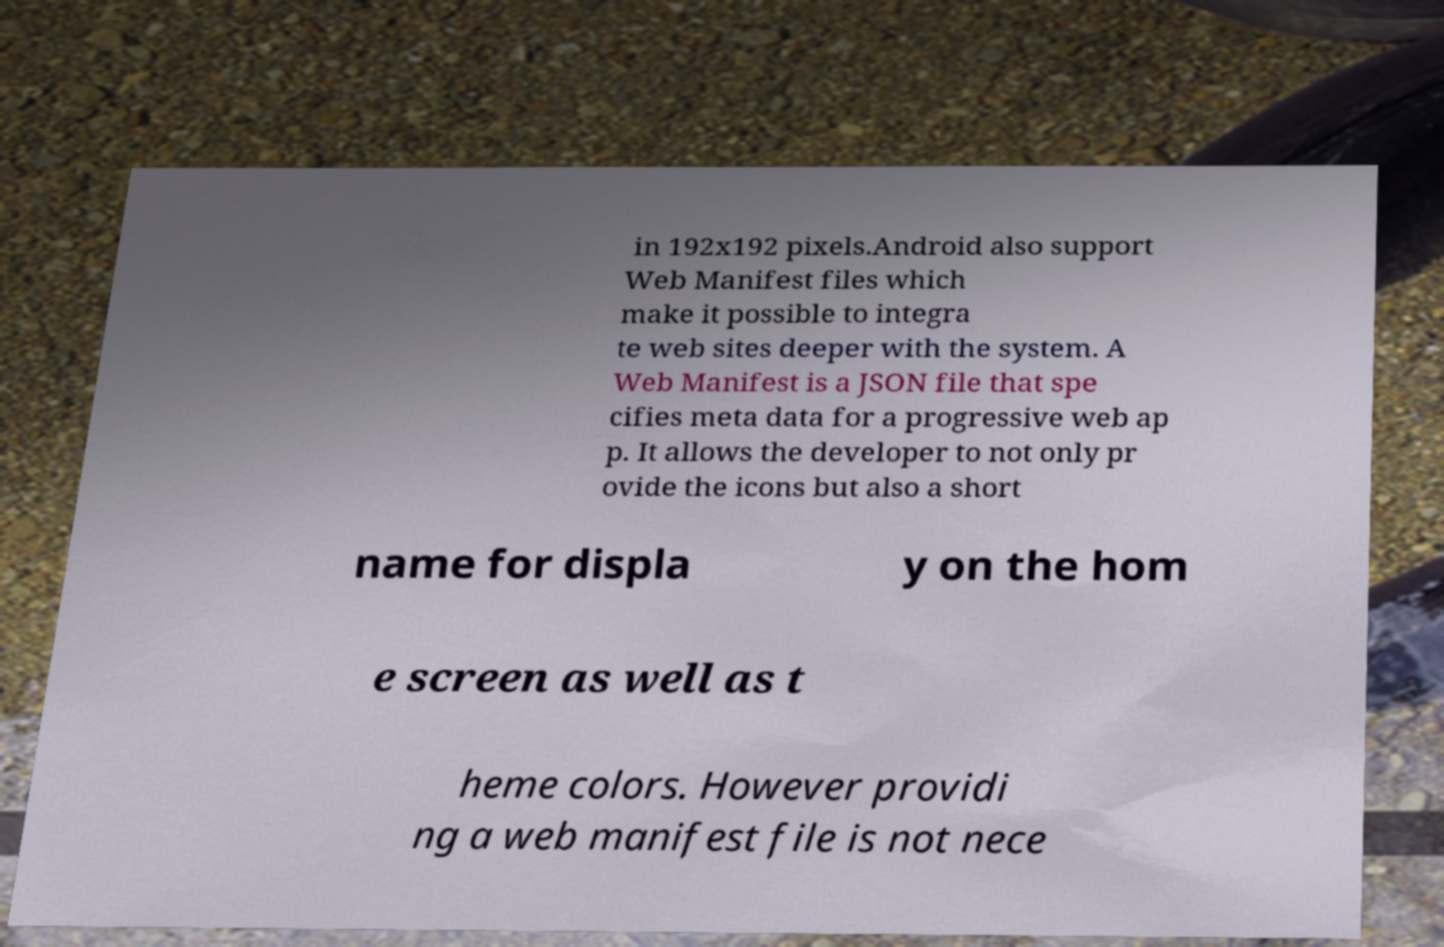Can you read and provide the text displayed in the image?This photo seems to have some interesting text. Can you extract and type it out for me? in 192x192 pixels.Android also support Web Manifest files which make it possible to integra te web sites deeper with the system. A Web Manifest is a JSON file that spe cifies meta data for a progressive web ap p. It allows the developer to not only pr ovide the icons but also a short name for displa y on the hom e screen as well as t heme colors. However providi ng a web manifest file is not nece 